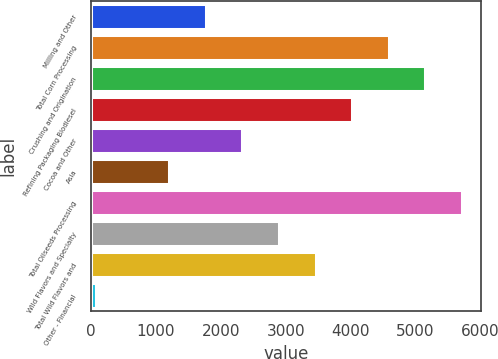Convert chart to OTSL. <chart><loc_0><loc_0><loc_500><loc_500><bar_chart><fcel>Milling and Other<fcel>Total Corn Processing<fcel>Crushing and Origination<fcel>Refining Packaging Biodiesel<fcel>Cocoa and Other<fcel>Asia<fcel>Total Oilseeds Processing<fcel>Wild Flavors and Specialty<fcel>Total Wild Flavors and<fcel>Other - Financial<nl><fcel>1764.5<fcel>4587<fcel>5151.5<fcel>4022.5<fcel>2329<fcel>1200<fcel>5716<fcel>2893.5<fcel>3458<fcel>71<nl></chart> 